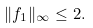Convert formula to latex. <formula><loc_0><loc_0><loc_500><loc_500>\| f _ { 1 } \| _ { \infty } \leq 2 .</formula> 